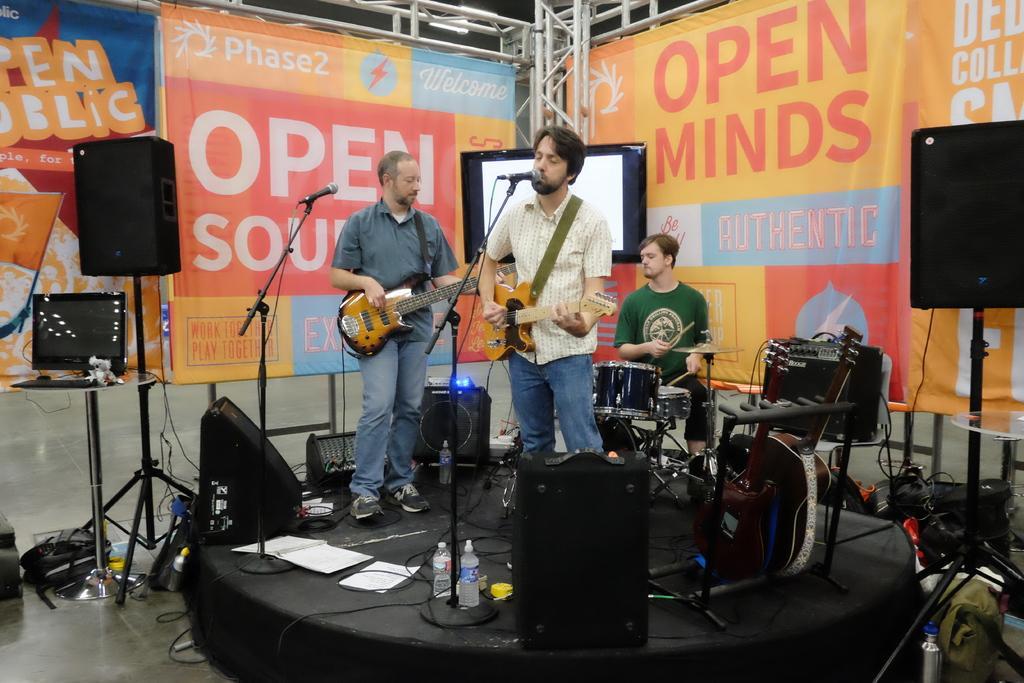In one or two sentences, can you explain what this image depicts? In this picture there are two men who are playing a guitar. There is a mic. There is a man sitting on a chair holding a stick in his hand. There is a drum, guitar, bottles, light and few other objects on table. There is a laptop on the table. There is a poster at the background. There is a bag. 